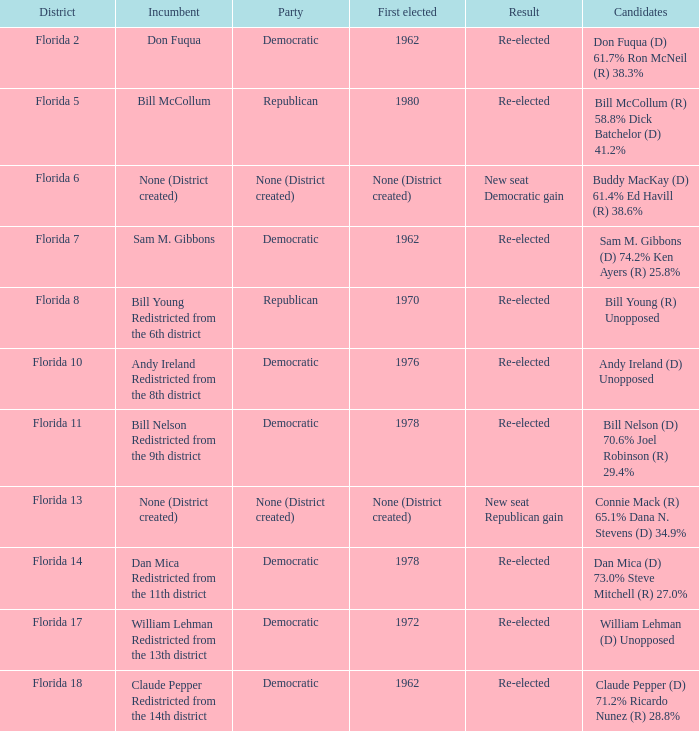How many contenders with result being new seat democratic increase? 1.0. 